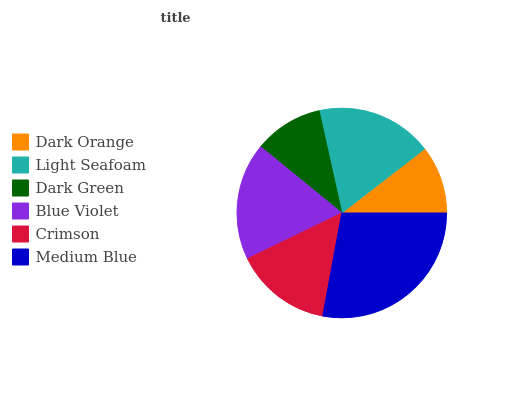Is Dark Orange the minimum?
Answer yes or no. Yes. Is Medium Blue the maximum?
Answer yes or no. Yes. Is Light Seafoam the minimum?
Answer yes or no. No. Is Light Seafoam the maximum?
Answer yes or no. No. Is Light Seafoam greater than Dark Orange?
Answer yes or no. Yes. Is Dark Orange less than Light Seafoam?
Answer yes or no. Yes. Is Dark Orange greater than Light Seafoam?
Answer yes or no. No. Is Light Seafoam less than Dark Orange?
Answer yes or no. No. Is Light Seafoam the high median?
Answer yes or no. Yes. Is Crimson the low median?
Answer yes or no. Yes. Is Blue Violet the high median?
Answer yes or no. No. Is Medium Blue the low median?
Answer yes or no. No. 